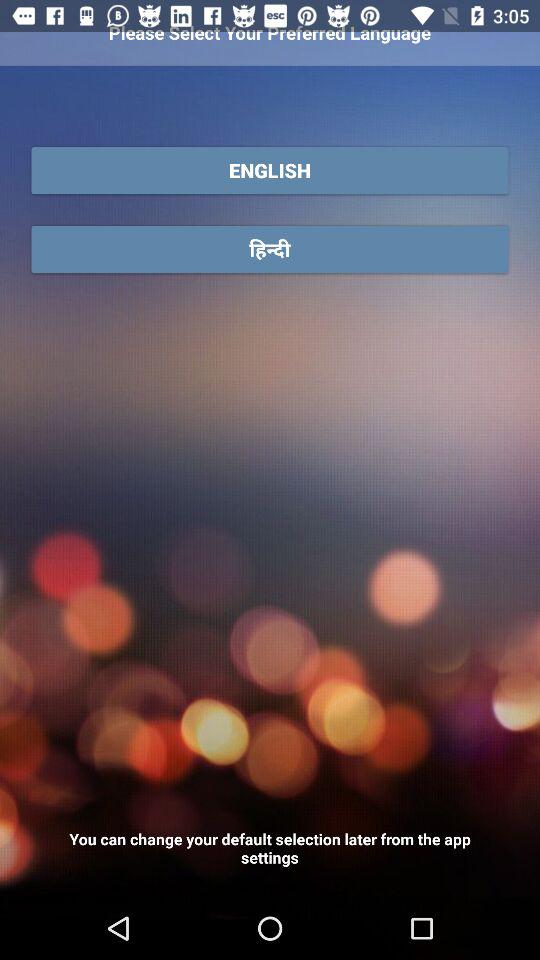How many languages are available for selection?
Answer the question using a single word or phrase. 2 